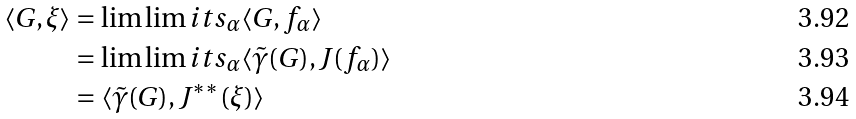<formula> <loc_0><loc_0><loc_500><loc_500>\langle G , \xi \rangle & = \lim \lim i t s _ { \alpha } \langle G , f _ { \alpha } \rangle \\ & = \lim \lim i t s _ { \alpha } \langle \tilde { \gamma } ( G ) , J ( f _ { \alpha } ) \rangle \\ & = \langle \tilde { \gamma } ( G ) , J ^ { * * } ( \xi ) \rangle</formula> 